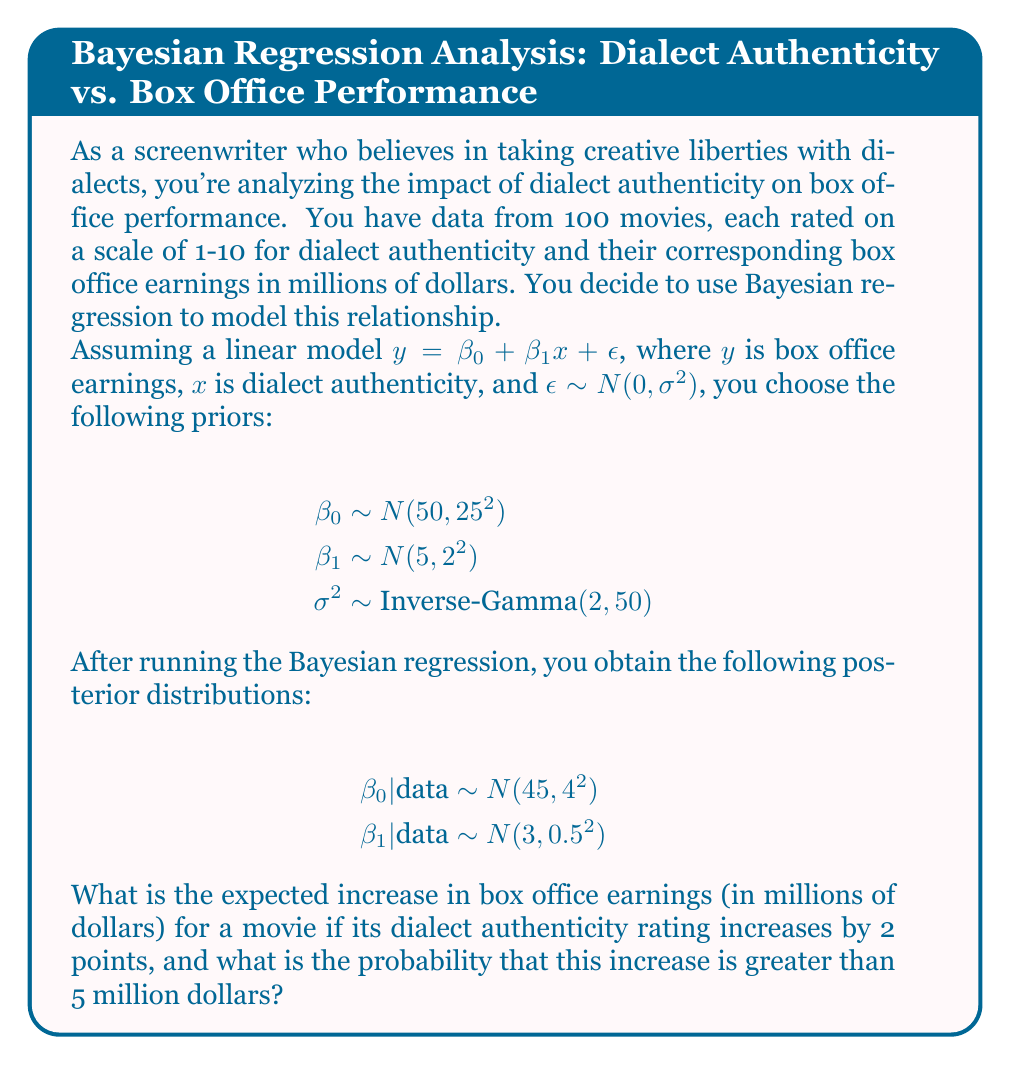Help me with this question. To solve this problem, we'll follow these steps:

1. Calculate the expected increase in box office earnings:
   The posterior distribution for $\beta_1$ represents the change in earnings for a one-point increase in dialect authenticity.
   $\beta_1 | \text{data} \sim N(3, 0.5^2)$
   
   For a 2-point increase, we multiply the mean by 2:
   Expected increase = $2 \times 3 = 6$ million dollars

2. Calculate the probability that the increase is greater than 5 million dollars:
   We need to find $P(\beta_1 \times 2 > 5)$, which is equivalent to $P(\beta_1 > 2.5)$

   First, standardize the random variable:
   $Z = \frac{\beta_1 - \mu}{\sigma} = \frac{\beta_1 - 3}{0.5}$

   We want $P(\beta_1 > 2.5)$, which is equivalent to:
   $P(Z > \frac{2.5 - 3}{0.5}) = P(Z > -1)$

   Using the standard normal distribution table or a calculator:
   $P(Z > -1) = 1 - P(Z < -1) = 1 - 0.1587 = 0.8413$

Therefore, the probability that the increase is greater than 5 million dollars is approximately 0.8413 or 84.13%.
Answer: Expected increase: $6 million; Probability > $5 million: 0.8413 